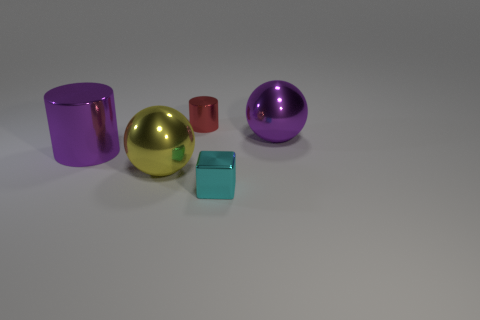Is there a small block of the same color as the big metallic cylinder?
Provide a succinct answer. No. Does the yellow object have the same material as the cyan thing?
Make the answer very short. Yes. There is a large yellow sphere; what number of big metal cylinders are behind it?
Offer a terse response. 1. The object that is both in front of the purple ball and on the right side of the red cylinder is made of what material?
Provide a short and direct response. Metal. How many metallic spheres are the same size as the red cylinder?
Give a very brief answer. 0. What is the color of the small object that is in front of the tiny object that is left of the cyan metallic cube?
Ensure brevity in your answer.  Cyan. Is there a small cyan shiny cube?
Your answer should be compact. Yes. Do the red object and the big yellow shiny thing have the same shape?
Your answer should be very brief. No. What size is the metallic object that is the same color as the big shiny cylinder?
Offer a terse response. Large. How many cylinders are on the right side of the large purple thing left of the shiny block?
Your response must be concise. 1. 